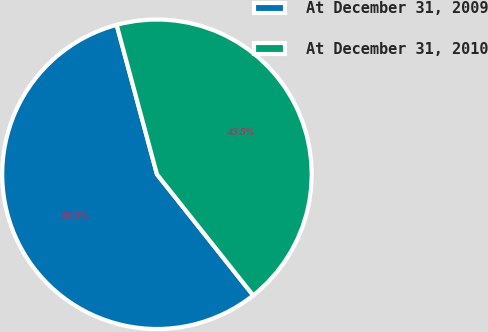Convert chart to OTSL. <chart><loc_0><loc_0><loc_500><loc_500><pie_chart><fcel>At December 31, 2009<fcel>At December 31, 2010<nl><fcel>56.49%<fcel>43.51%<nl></chart> 